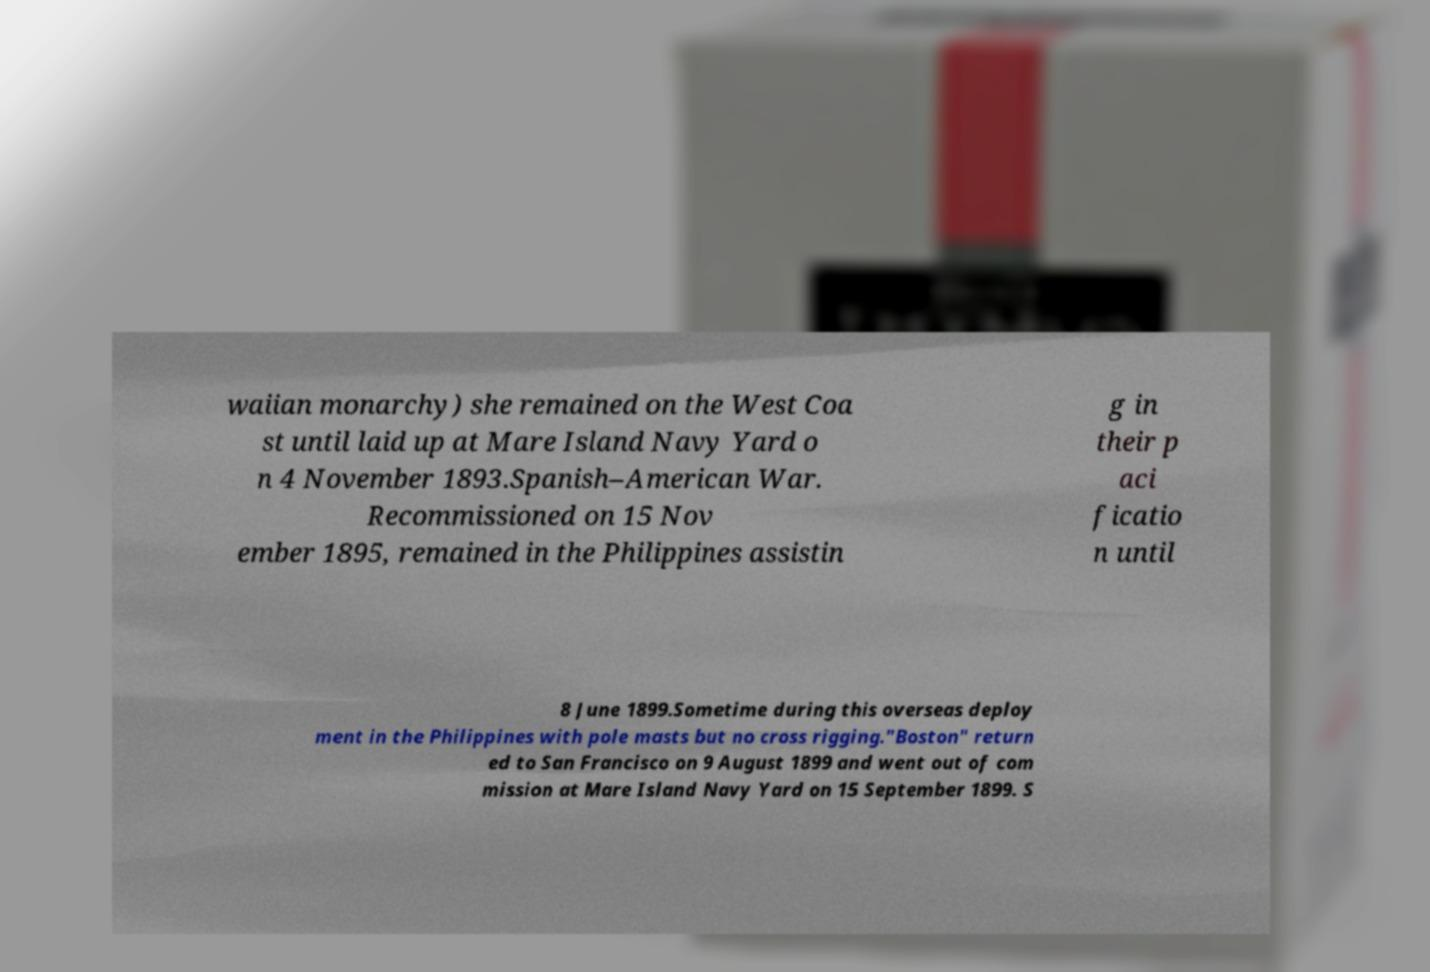There's text embedded in this image that I need extracted. Can you transcribe it verbatim? waiian monarchy) she remained on the West Coa st until laid up at Mare Island Navy Yard o n 4 November 1893.Spanish–American War. Recommissioned on 15 Nov ember 1895, remained in the Philippines assistin g in their p aci ficatio n until 8 June 1899.Sometime during this overseas deploy ment in the Philippines with pole masts but no cross rigging."Boston" return ed to San Francisco on 9 August 1899 and went out of com mission at Mare Island Navy Yard on 15 September 1899. S 